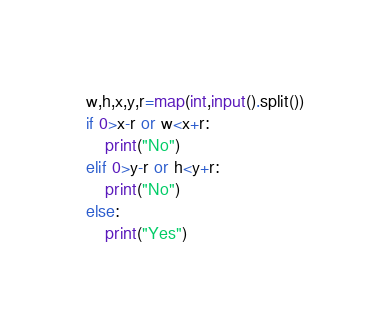<code> <loc_0><loc_0><loc_500><loc_500><_Python_>w,h,x,y,r=map(int,input().split())
if 0>x-r or w<x+r:
    print("No")
elif 0>y-r or h<y+r:
    print("No")
else:
    print("Yes")</code> 